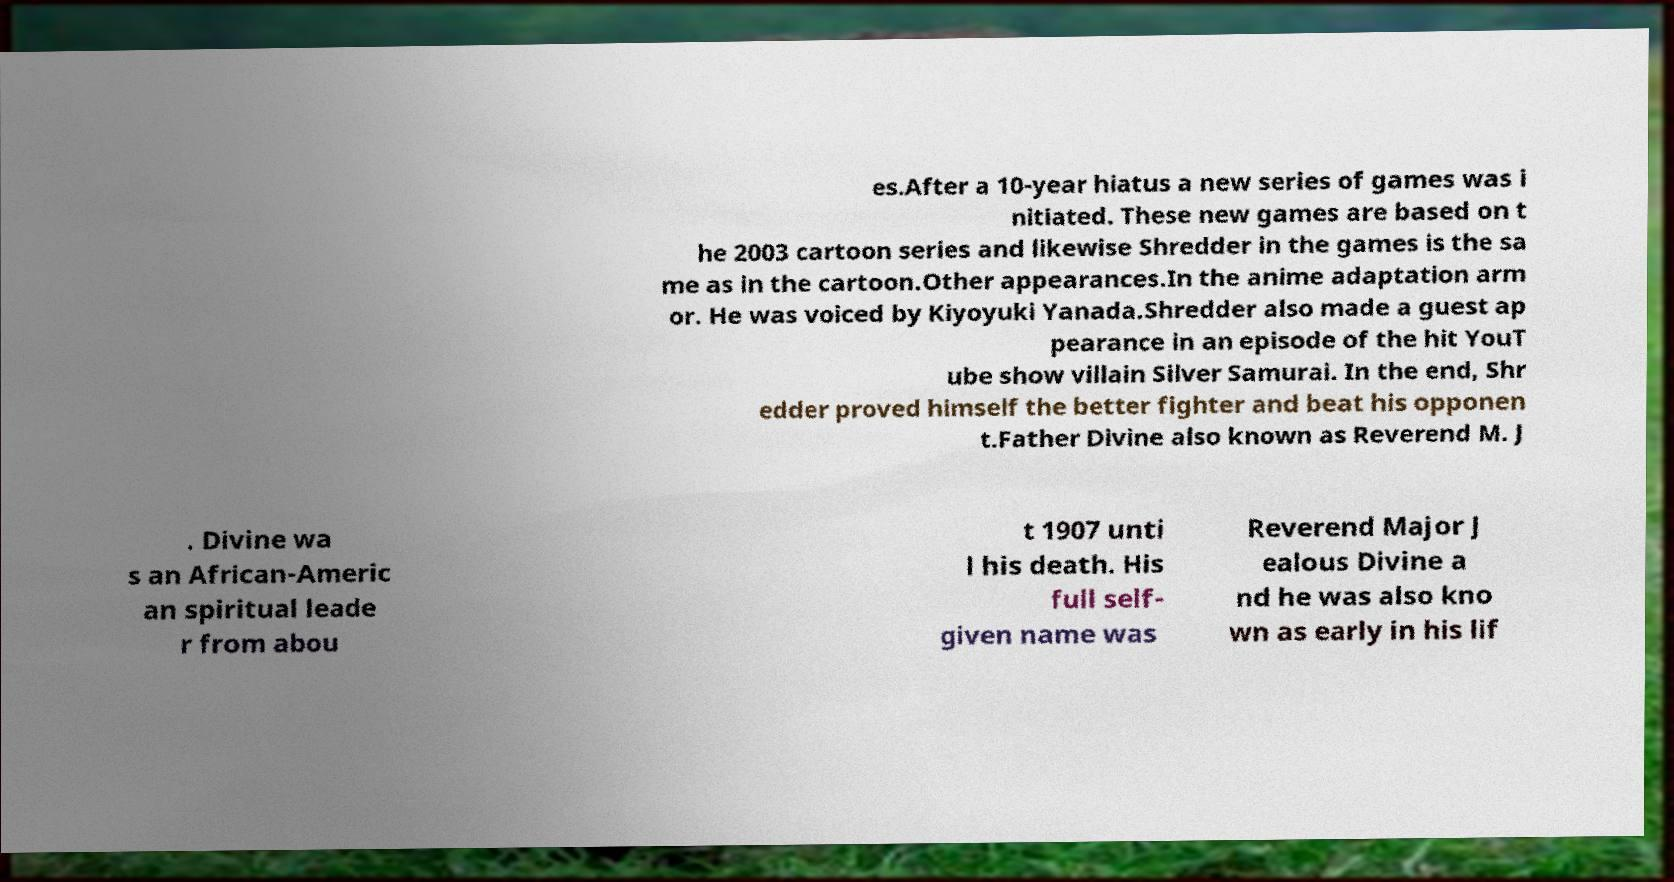Please identify and transcribe the text found in this image. es.After a 10-year hiatus a new series of games was i nitiated. These new games are based on t he 2003 cartoon series and likewise Shredder in the games is the sa me as in the cartoon.Other appearances.In the anime adaptation arm or. He was voiced by Kiyoyuki Yanada.Shredder also made a guest ap pearance in an episode of the hit YouT ube show villain Silver Samurai. In the end, Shr edder proved himself the better fighter and beat his opponen t.Father Divine also known as Reverend M. J . Divine wa s an African-Americ an spiritual leade r from abou t 1907 unti l his death. His full self- given name was Reverend Major J ealous Divine a nd he was also kno wn as early in his lif 